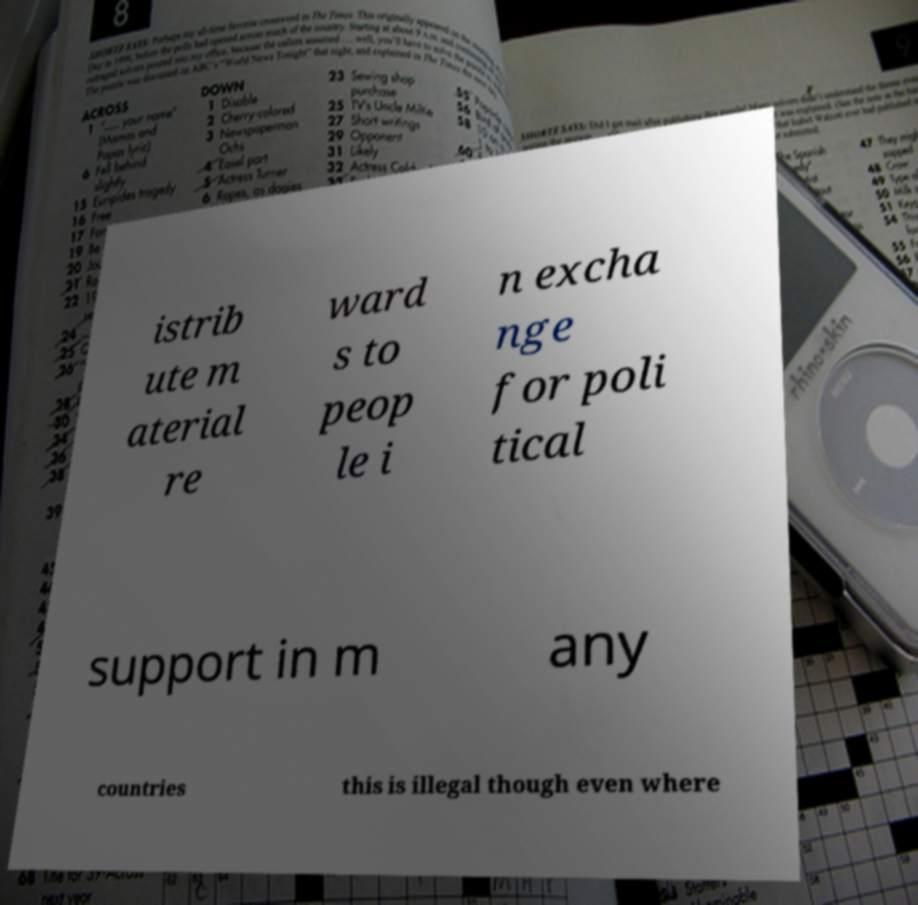What messages or text are displayed in this image? I need them in a readable, typed format. istrib ute m aterial re ward s to peop le i n excha nge for poli tical support in m any countries this is illegal though even where 